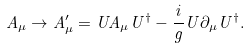<formula> <loc_0><loc_0><loc_500><loc_500>A _ { \mu } \rightarrow A ^ { \prime } _ { \mu } = U A _ { \mu } U ^ { \dagger } - \frac { i } { g } U \partial _ { \mu } U ^ { \dagger } .</formula> 